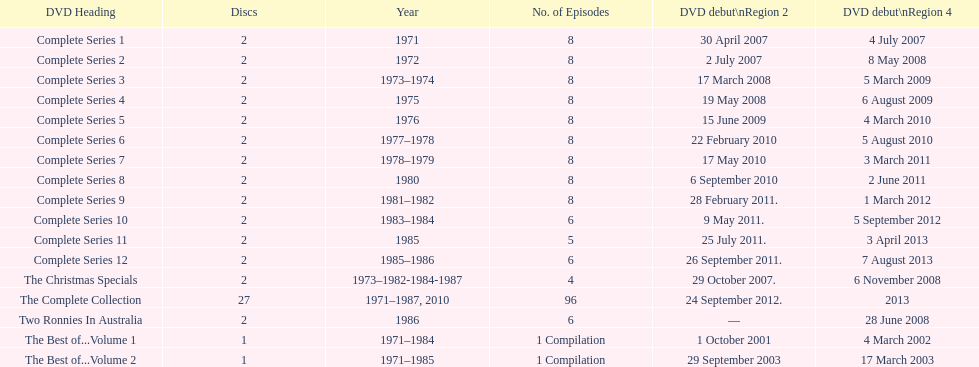Dvd shorter than 5 episodes The Christmas Specials. 